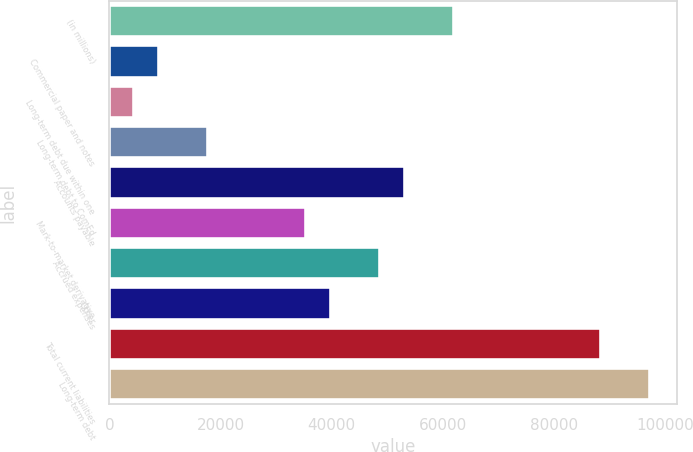<chart> <loc_0><loc_0><loc_500><loc_500><bar_chart><fcel>(in millions)<fcel>Commercial paper and notes<fcel>Long-term debt due within one<fcel>Long-term debt to ComEd<fcel>Accounts payable<fcel>Mark-to-market derivative<fcel>Accrued expenses<fcel>Other<fcel>Total current liabilities<fcel>Long-term debt<nl><fcel>62011.8<fcel>8933.4<fcel>4510.2<fcel>17779.8<fcel>53165.4<fcel>35472.6<fcel>48742.2<fcel>39895.8<fcel>88551<fcel>97397.4<nl></chart> 